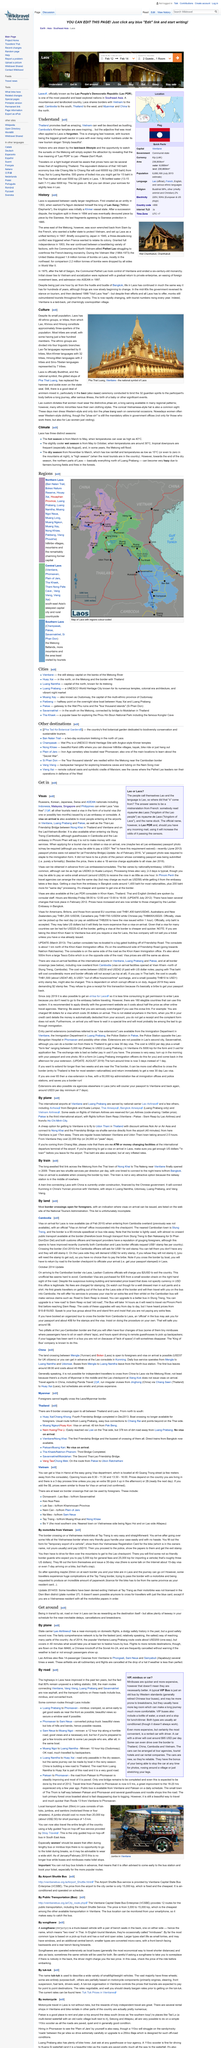Draw attention to some important aspects in this diagram. The ethnic groups are divided into four linguistic branches, namely Lao-Tai, Mon-Khmer, Hmong-Mien, and Sino-Tibetan. In 2014, a one-way ticket for the Vientiane-Luang Prabang route cost approximately USD 200. Lao Airlines operates several passenger Cessnas weekly, flying from Vientiane to Phongsali, Sam Neua, and Sainyabuli, carrying a total of 14 passengers each. Lao Airlines frequently cancel flights, and it is not an uncommon occurrence. Laos has 49 ethnic groups or tribes, as reported. 